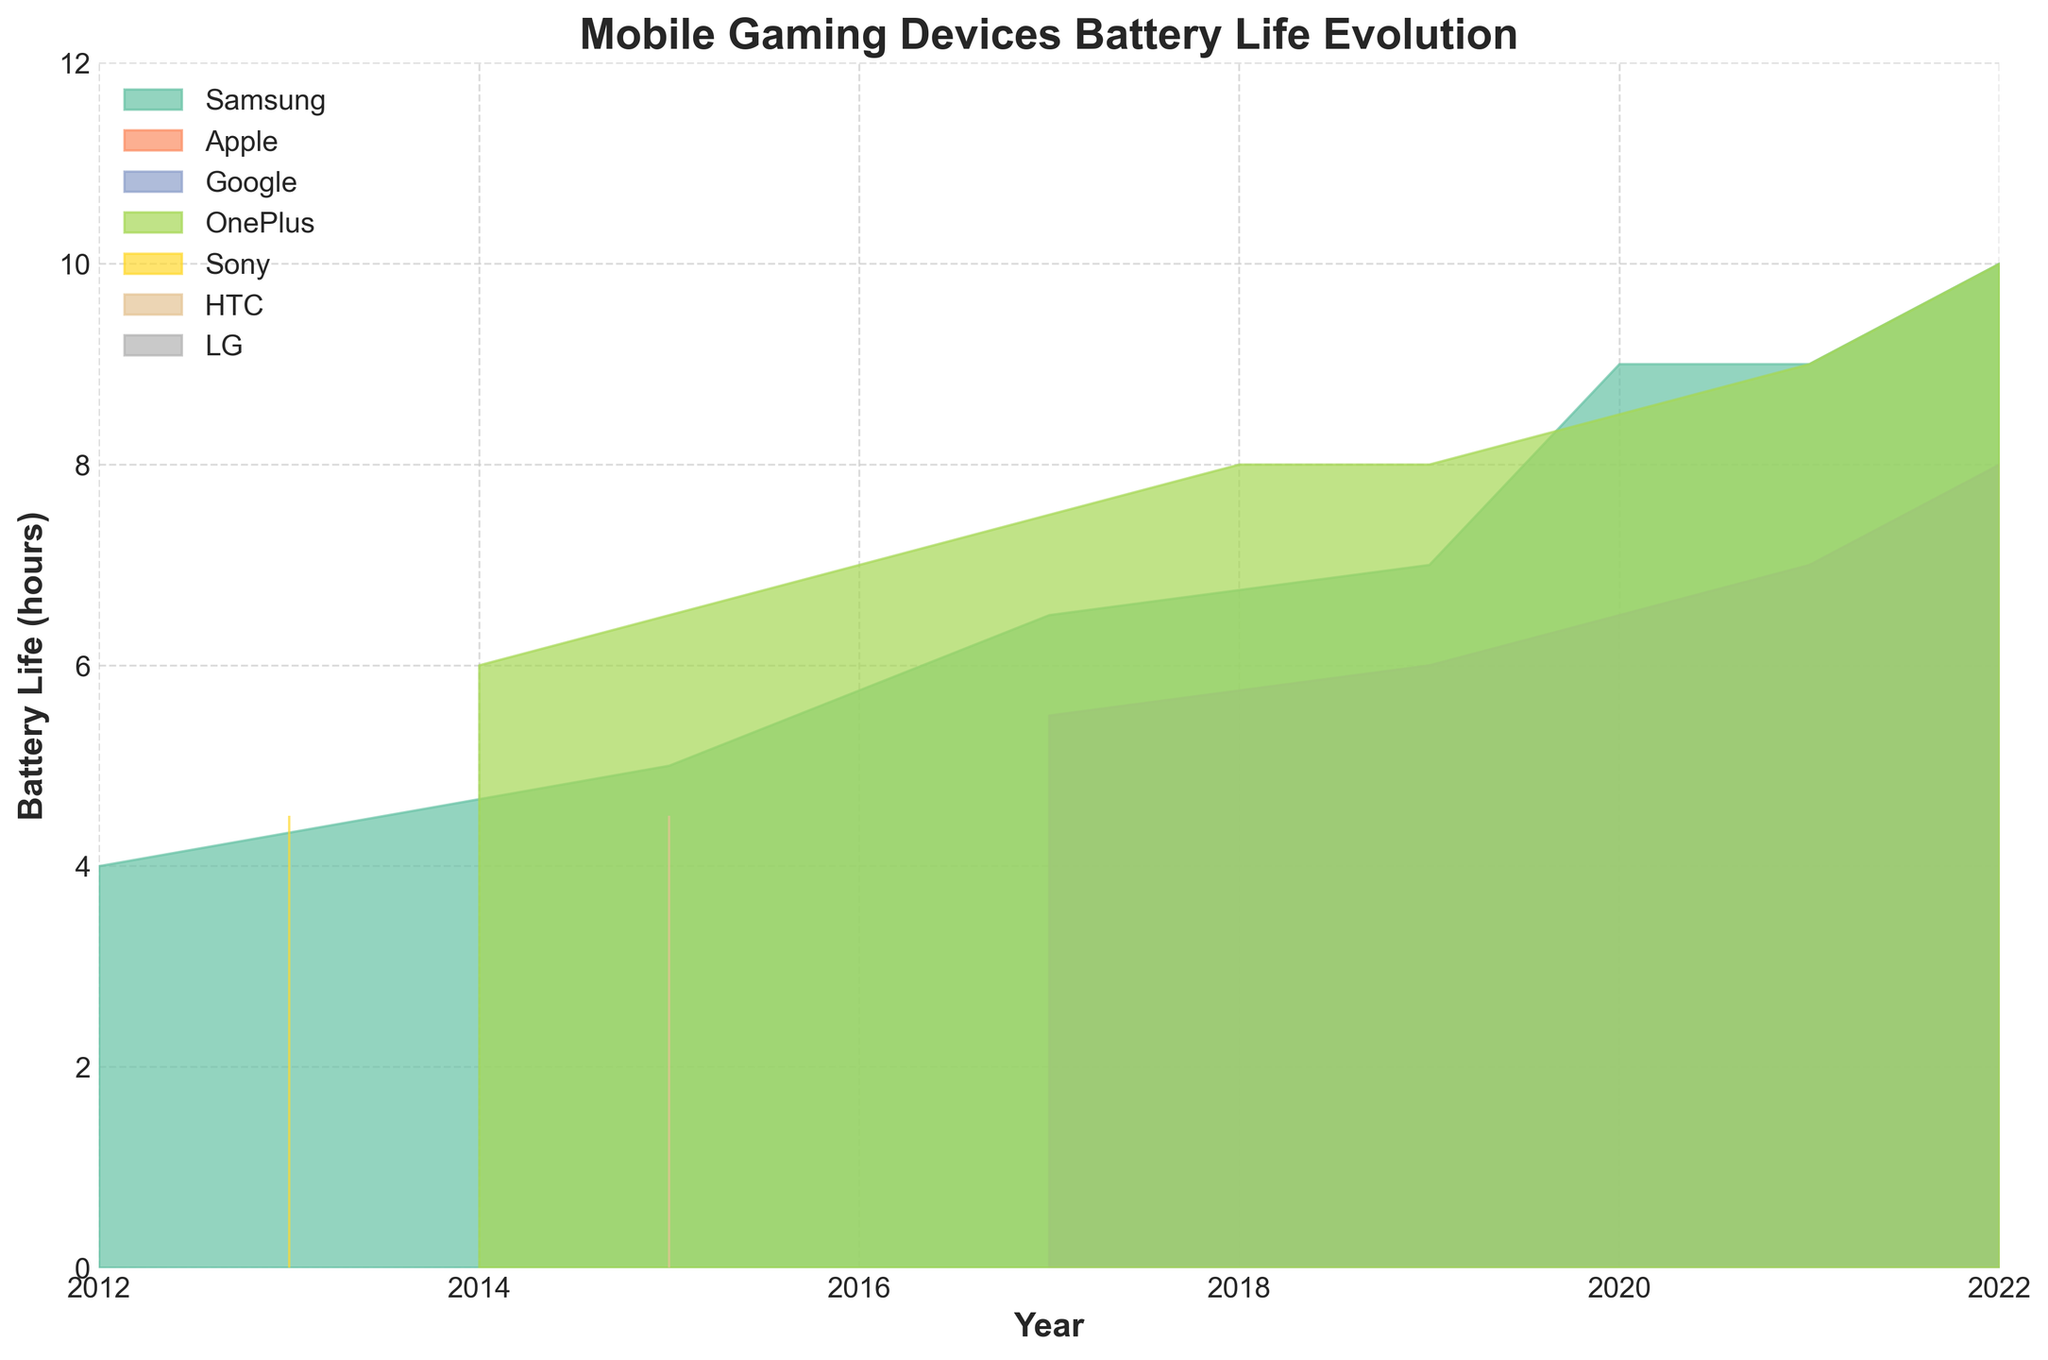What is the title of the area chart? The title is usually at the top of the chart in a large, bold font. By reading it directly, you can identify the topic of the area chart.
Answer: Mobile Gaming Devices Battery Life Evolution What is the battery life of the Samsung Galaxy S22 in 2022? To find the battery life, locate the point corresponding to the Samsung Galaxy S22 on the x-axis (2022) and then look at the y-axis to read the value.
Answer: 10 Which device had the highest battery life in 2018? To determine the highest battery life, find the year 2018 on the x-axis. Then look at the y-axis values for each device in that year and identify the one with the highest value.
Answer: OnePlus 6 Between which years did OnePlus devices show the most significant increase in battery life? Look for the OnePlus devices on the chart. Observe the changes in the y-axis (battery life) and identify the years where there is a noticeable increase in the area shaded for OnePlus.
Answer: 2017 to 2018 How does the battery life of Apple devices progress from 2012 to 2022? Follow the area for Apple devices starting from the year 2012 to 2022. Note the changes in the y-axis values to understand the progression.
Answer: It generally increases over time Which device had the lowest battery life in 2013? To find the lowest battery life, locate the year 2013 on the x-axis. Compare the y-axis values for each device and note the one with the lowest value.
Answer: Sony Xperia Z How does the battery life of Samsung devices in 2020 compare to 2021? Locate the Samsung devices for the years 2020 and 2021 on the x-axis. Compare the battery life values on the y-axis for these two years.
Answer: The battery life increased from 9 to 10 hours What was the average battery life of all devices in 2015? Locate the year 2015. Add the battery life values for Samsung Galaxy S6 and HTC One M9, then divide by 2 to calculate the average.
Answer: (5 + 4.5) / 2 = 4.75 How many different manufacturers' devices are represented in the chart? Count the distinct segments or areas representing different manufacturers on the chart.
Answer: 7 Which year shows the maximum combined battery life across all devices? Identify the year where the summation of all individual battery life values is the highest. This requires summing the y-axis values for each device in each year and comparing the results.
Answer: 2022 